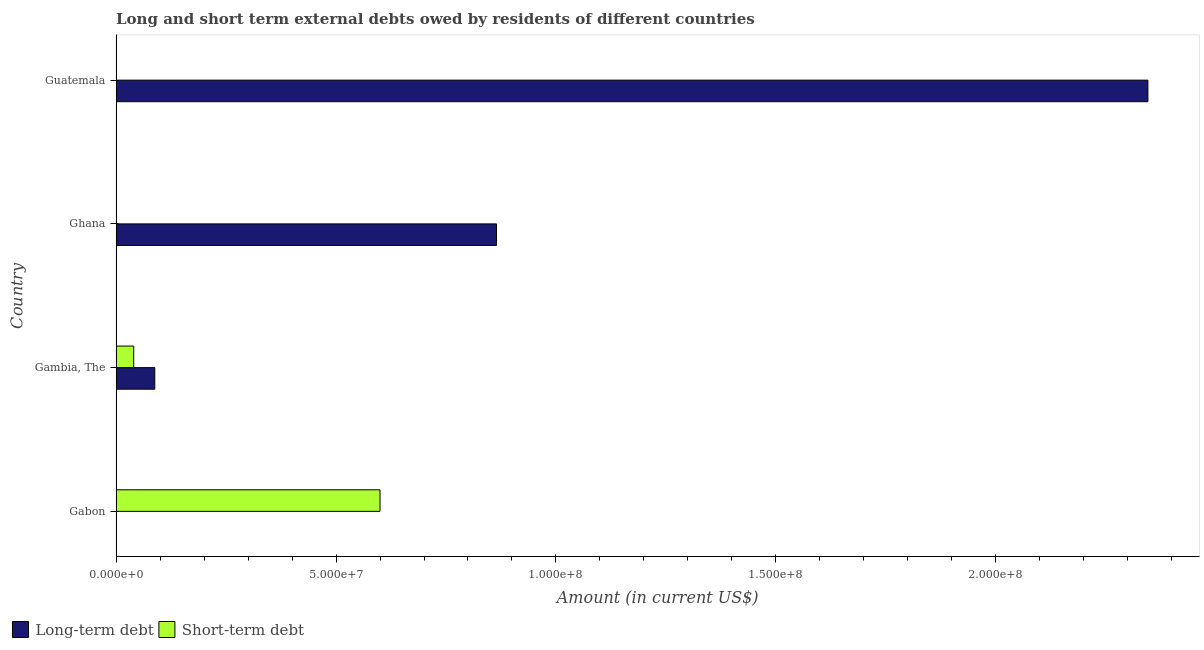Are the number of bars on each tick of the Y-axis equal?
Your response must be concise. No. What is the label of the 3rd group of bars from the top?
Give a very brief answer. Gambia, The. In how many cases, is the number of bars for a given country not equal to the number of legend labels?
Provide a succinct answer. 3. What is the short-term debts owed by residents in Guatemala?
Offer a very short reply. 0. Across all countries, what is the maximum long-term debts owed by residents?
Your answer should be compact. 2.35e+08. Across all countries, what is the minimum long-term debts owed by residents?
Provide a short and direct response. 0. In which country was the long-term debts owed by residents maximum?
Your response must be concise. Guatemala. What is the total short-term debts owed by residents in the graph?
Your answer should be compact. 6.40e+07. What is the difference between the short-term debts owed by residents in Gabon and that in Gambia, The?
Make the answer very short. 5.60e+07. What is the difference between the short-term debts owed by residents in Guatemala and the long-term debts owed by residents in Gabon?
Your answer should be very brief. 0. What is the average long-term debts owed by residents per country?
Your response must be concise. 8.25e+07. What is the difference between the short-term debts owed by residents and long-term debts owed by residents in Gambia, The?
Provide a succinct answer. -4.79e+06. What is the ratio of the long-term debts owed by residents in Gambia, The to that in Ghana?
Your response must be concise. 0.1. What is the difference between the highest and the second highest long-term debts owed by residents?
Ensure brevity in your answer.  1.48e+08. What is the difference between the highest and the lowest long-term debts owed by residents?
Your answer should be very brief. 2.35e+08. In how many countries, is the short-term debts owed by residents greater than the average short-term debts owed by residents taken over all countries?
Your response must be concise. 1. How many bars are there?
Your response must be concise. 5. Are all the bars in the graph horizontal?
Ensure brevity in your answer.  Yes. How many countries are there in the graph?
Provide a short and direct response. 4. What is the difference between two consecutive major ticks on the X-axis?
Keep it short and to the point. 5.00e+07. Are the values on the major ticks of X-axis written in scientific E-notation?
Your answer should be very brief. Yes. Does the graph contain any zero values?
Keep it short and to the point. Yes. Where does the legend appear in the graph?
Provide a succinct answer. Bottom left. How many legend labels are there?
Provide a succinct answer. 2. How are the legend labels stacked?
Your response must be concise. Horizontal. What is the title of the graph?
Provide a short and direct response. Long and short term external debts owed by residents of different countries. What is the label or title of the Y-axis?
Ensure brevity in your answer.  Country. What is the Amount (in current US$) in Long-term debt in Gabon?
Give a very brief answer. 0. What is the Amount (in current US$) of Short-term debt in Gabon?
Your answer should be compact. 6.00e+07. What is the Amount (in current US$) in Long-term debt in Gambia, The?
Your answer should be very brief. 8.79e+06. What is the Amount (in current US$) of Long-term debt in Ghana?
Your response must be concise. 8.65e+07. What is the Amount (in current US$) in Long-term debt in Guatemala?
Your response must be concise. 2.35e+08. Across all countries, what is the maximum Amount (in current US$) of Long-term debt?
Offer a very short reply. 2.35e+08. Across all countries, what is the maximum Amount (in current US$) of Short-term debt?
Provide a short and direct response. 6.00e+07. What is the total Amount (in current US$) of Long-term debt in the graph?
Offer a very short reply. 3.30e+08. What is the total Amount (in current US$) in Short-term debt in the graph?
Make the answer very short. 6.40e+07. What is the difference between the Amount (in current US$) of Short-term debt in Gabon and that in Gambia, The?
Offer a terse response. 5.60e+07. What is the difference between the Amount (in current US$) in Long-term debt in Gambia, The and that in Ghana?
Make the answer very short. -7.77e+07. What is the difference between the Amount (in current US$) in Long-term debt in Gambia, The and that in Guatemala?
Provide a short and direct response. -2.26e+08. What is the difference between the Amount (in current US$) of Long-term debt in Ghana and that in Guatemala?
Keep it short and to the point. -1.48e+08. What is the average Amount (in current US$) in Long-term debt per country?
Provide a short and direct response. 8.25e+07. What is the average Amount (in current US$) of Short-term debt per country?
Provide a short and direct response. 1.60e+07. What is the difference between the Amount (in current US$) of Long-term debt and Amount (in current US$) of Short-term debt in Gambia, The?
Give a very brief answer. 4.79e+06. What is the ratio of the Amount (in current US$) in Long-term debt in Gambia, The to that in Ghana?
Provide a short and direct response. 0.1. What is the ratio of the Amount (in current US$) of Long-term debt in Gambia, The to that in Guatemala?
Your answer should be compact. 0.04. What is the ratio of the Amount (in current US$) in Long-term debt in Ghana to that in Guatemala?
Make the answer very short. 0.37. What is the difference between the highest and the second highest Amount (in current US$) in Long-term debt?
Provide a succinct answer. 1.48e+08. What is the difference between the highest and the lowest Amount (in current US$) in Long-term debt?
Offer a terse response. 2.35e+08. What is the difference between the highest and the lowest Amount (in current US$) in Short-term debt?
Provide a succinct answer. 6.00e+07. 